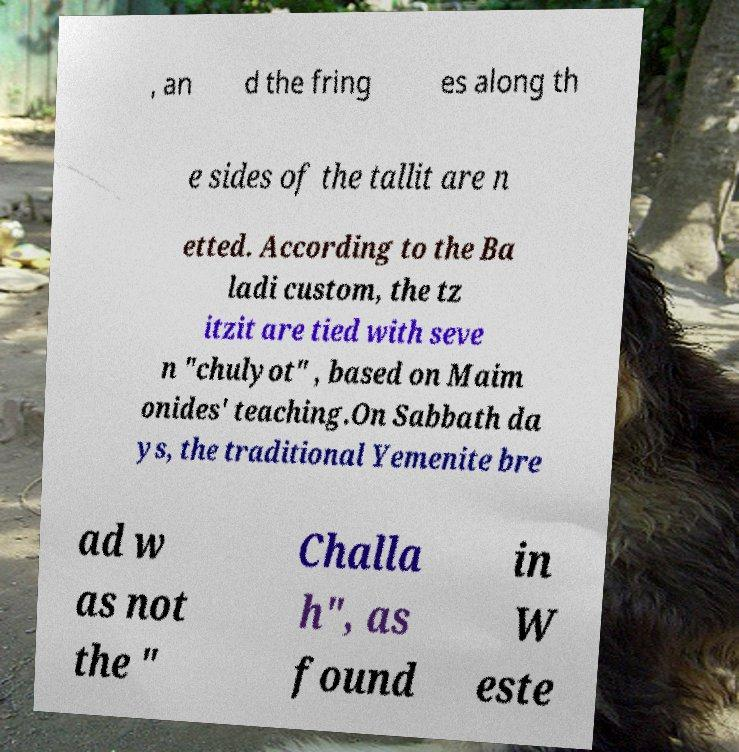Please read and relay the text visible in this image. What does it say? , an d the fring es along th e sides of the tallit are n etted. According to the Ba ladi custom, the tz itzit are tied with seve n "chulyot" , based on Maim onides' teaching.On Sabbath da ys, the traditional Yemenite bre ad w as not the " Challa h", as found in W este 